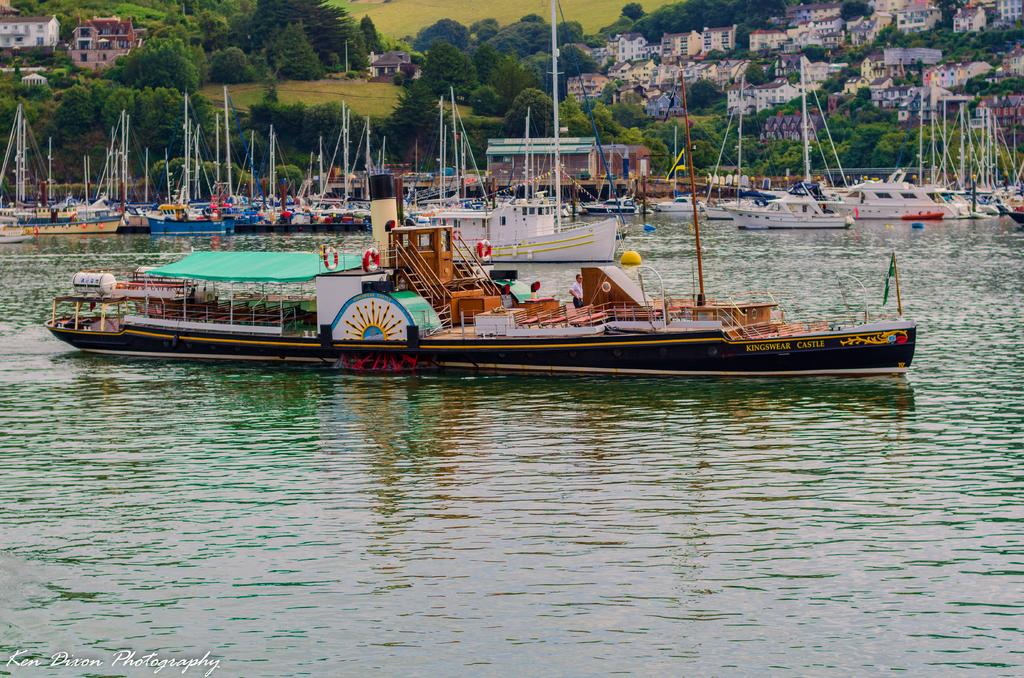What is located in the water in the image? There are ships in the water in the image. What can be seen in the background of the image? There are buildings, trees, and poles in the background of the image. Is there any text present in the image? Yes, there is some text at the bottom of the image. What type of floor can be seen in the image? There is no floor visible in the image, as it features ships in the water and various elements in the background. 